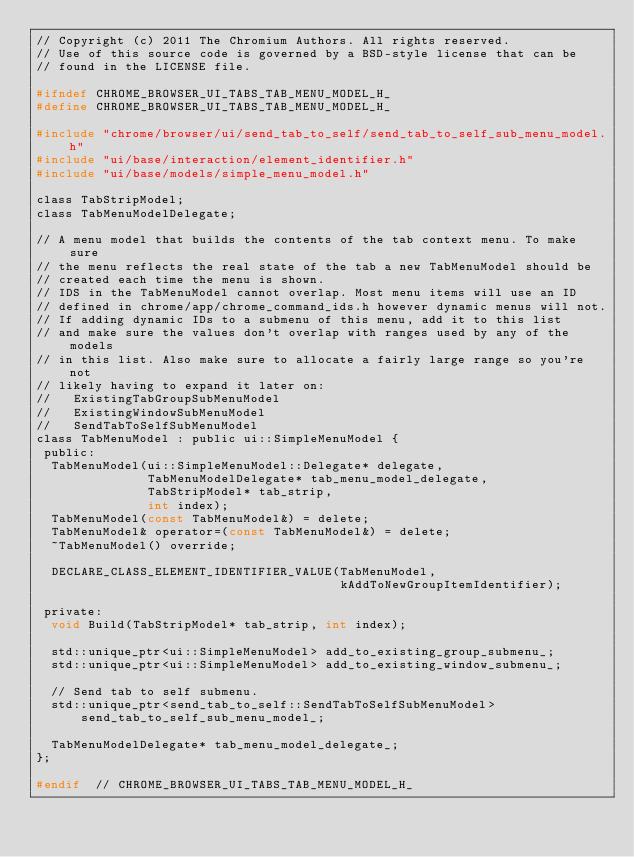<code> <loc_0><loc_0><loc_500><loc_500><_C_>// Copyright (c) 2011 The Chromium Authors. All rights reserved.
// Use of this source code is governed by a BSD-style license that can be
// found in the LICENSE file.

#ifndef CHROME_BROWSER_UI_TABS_TAB_MENU_MODEL_H_
#define CHROME_BROWSER_UI_TABS_TAB_MENU_MODEL_H_

#include "chrome/browser/ui/send_tab_to_self/send_tab_to_self_sub_menu_model.h"
#include "ui/base/interaction/element_identifier.h"
#include "ui/base/models/simple_menu_model.h"

class TabStripModel;
class TabMenuModelDelegate;

// A menu model that builds the contents of the tab context menu. To make sure
// the menu reflects the real state of the tab a new TabMenuModel should be
// created each time the menu is shown.
// IDS in the TabMenuModel cannot overlap. Most menu items will use an ID
// defined in chrome/app/chrome_command_ids.h however dynamic menus will not.
// If adding dynamic IDs to a submenu of this menu, add it to this list
// and make sure the values don't overlap with ranges used by any of the models
// in this list. Also make sure to allocate a fairly large range so you're not
// likely having to expand it later on:
//   ExistingTabGroupSubMenuModel
//   ExistingWindowSubMenuModel
//   SendTabToSelfSubMenuModel
class TabMenuModel : public ui::SimpleMenuModel {
 public:
  TabMenuModel(ui::SimpleMenuModel::Delegate* delegate,
               TabMenuModelDelegate* tab_menu_model_delegate,
               TabStripModel* tab_strip,
               int index);
  TabMenuModel(const TabMenuModel&) = delete;
  TabMenuModel& operator=(const TabMenuModel&) = delete;
  ~TabMenuModel() override;

  DECLARE_CLASS_ELEMENT_IDENTIFIER_VALUE(TabMenuModel,
                                         kAddToNewGroupItemIdentifier);

 private:
  void Build(TabStripModel* tab_strip, int index);

  std::unique_ptr<ui::SimpleMenuModel> add_to_existing_group_submenu_;
  std::unique_ptr<ui::SimpleMenuModel> add_to_existing_window_submenu_;

  // Send tab to self submenu.
  std::unique_ptr<send_tab_to_self::SendTabToSelfSubMenuModel>
      send_tab_to_self_sub_menu_model_;

  TabMenuModelDelegate* tab_menu_model_delegate_;
};

#endif  // CHROME_BROWSER_UI_TABS_TAB_MENU_MODEL_H_
</code> 